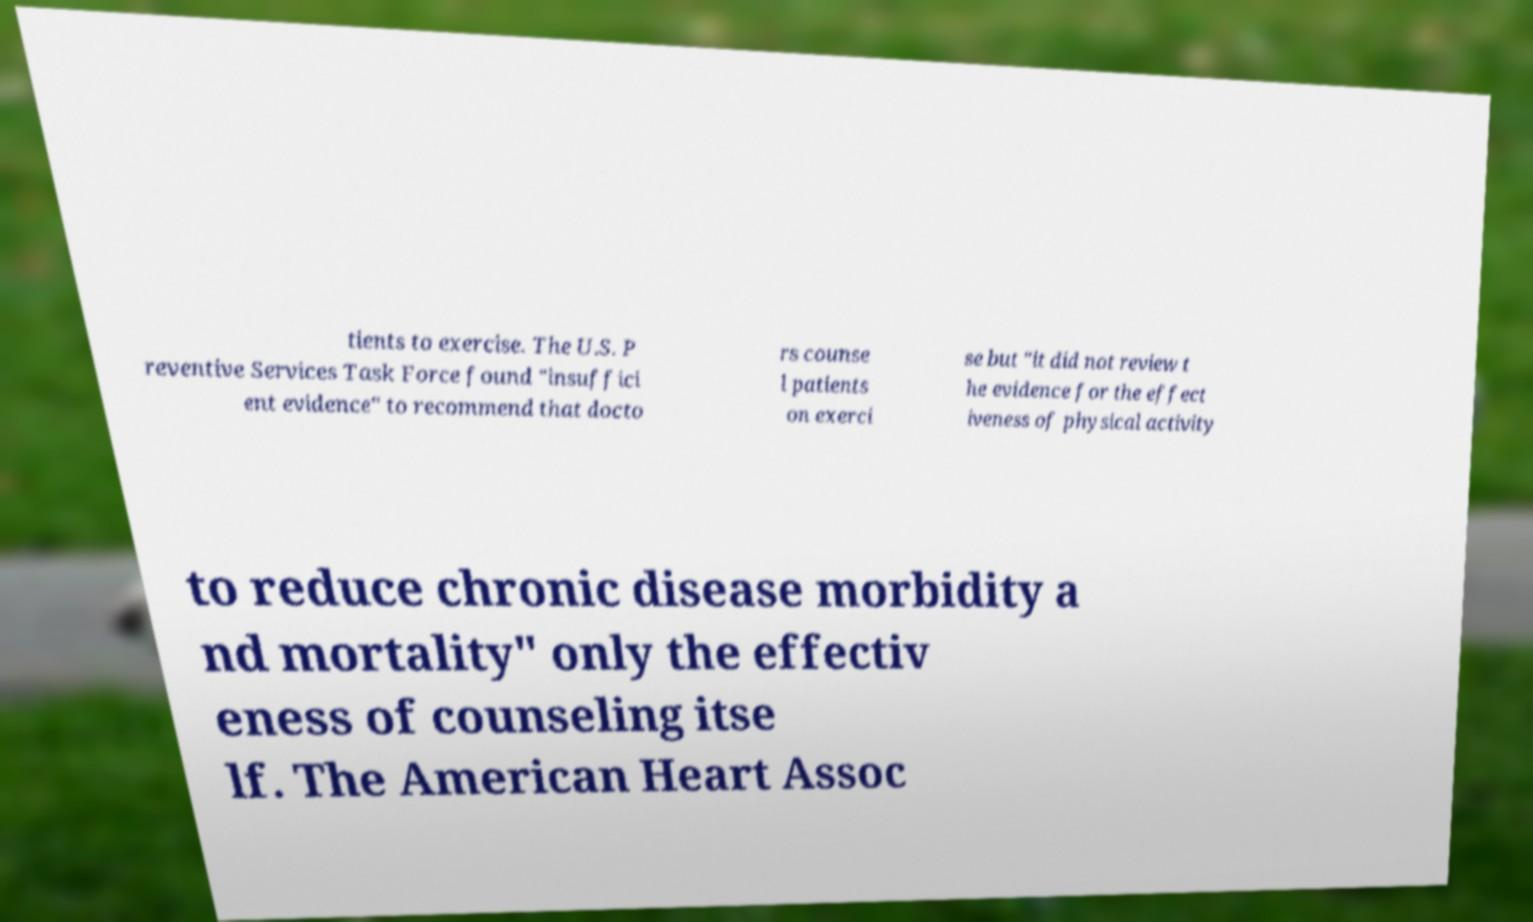Can you accurately transcribe the text from the provided image for me? tients to exercise. The U.S. P reventive Services Task Force found "insuffici ent evidence" to recommend that docto rs counse l patients on exerci se but "it did not review t he evidence for the effect iveness of physical activity to reduce chronic disease morbidity a nd mortality" only the effectiv eness of counseling itse lf. The American Heart Assoc 